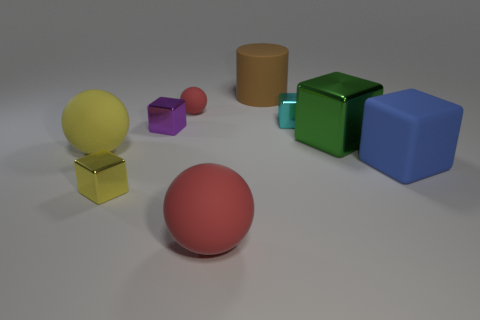What number of matte objects have the same color as the tiny matte sphere?
Provide a succinct answer. 1. Are there fewer tiny metallic blocks behind the small purple metal block than shiny cubes left of the cyan metal block?
Make the answer very short. Yes. How big is the red rubber ball that is behind the small purple metal block?
Provide a succinct answer. Small. The thing that is the same color as the small matte sphere is what size?
Offer a very short reply. Large. Is there a tiny red ball that has the same material as the big yellow thing?
Provide a short and direct response. Yes. Does the small purple block have the same material as the large yellow thing?
Ensure brevity in your answer.  No. The sphere that is the same size as the purple shiny thing is what color?
Your response must be concise. Red. What number of other things are the same shape as the green metal object?
Give a very brief answer. 4. There is a brown thing; is its size the same as the red matte ball that is in front of the small red sphere?
Your answer should be compact. Yes. How many objects are either big brown matte things or small balls?
Keep it short and to the point. 2. 